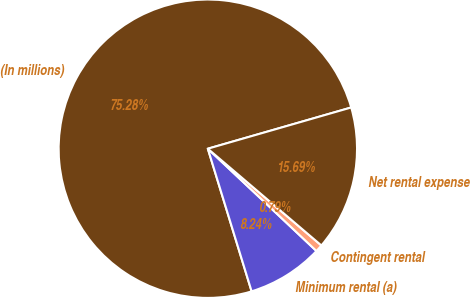Convert chart to OTSL. <chart><loc_0><loc_0><loc_500><loc_500><pie_chart><fcel>(In millions)<fcel>Minimum rental (a)<fcel>Contingent rental<fcel>Net rental expense<nl><fcel>75.29%<fcel>8.24%<fcel>0.79%<fcel>15.69%<nl></chart> 